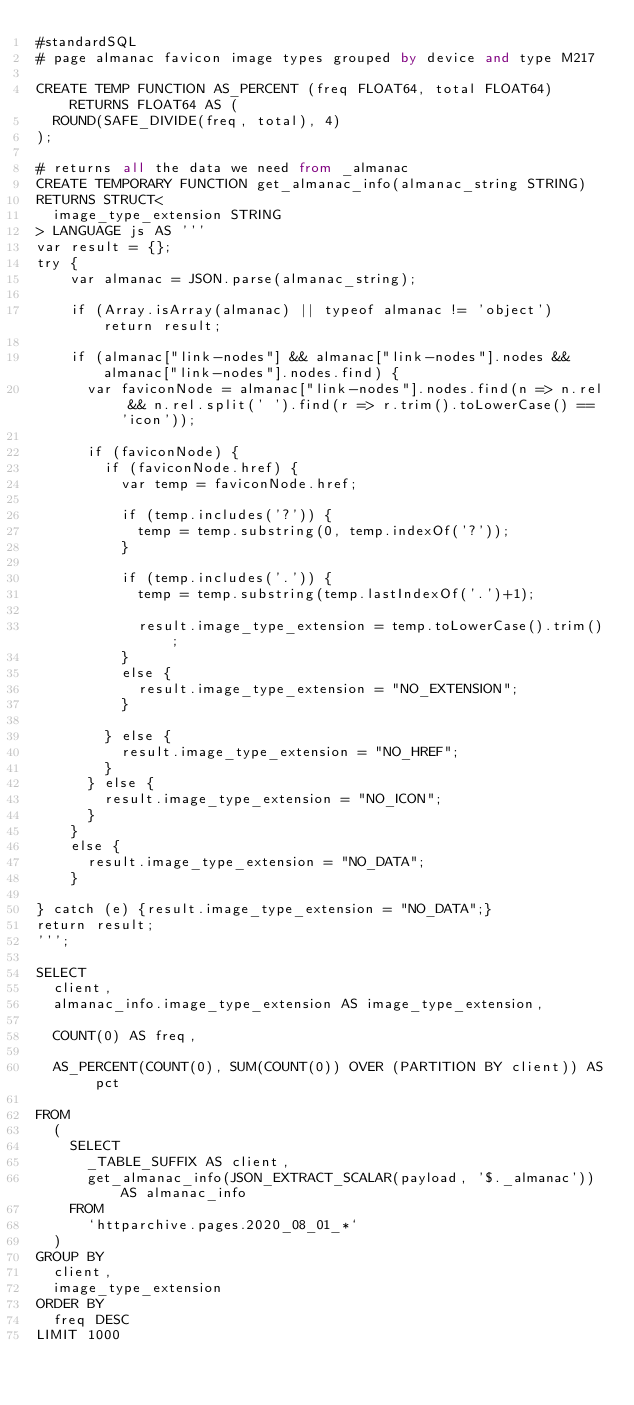<code> <loc_0><loc_0><loc_500><loc_500><_SQL_>#standardSQL
# page almanac favicon image types grouped by device and type M217

CREATE TEMP FUNCTION AS_PERCENT (freq FLOAT64, total FLOAT64) RETURNS FLOAT64 AS (
  ROUND(SAFE_DIVIDE(freq, total), 4)
);

# returns all the data we need from _almanac
CREATE TEMPORARY FUNCTION get_almanac_info(almanac_string STRING)
RETURNS STRUCT<
  image_type_extension STRING
> LANGUAGE js AS '''
var result = {};
try {
    var almanac = JSON.parse(almanac_string);

    if (Array.isArray(almanac) || typeof almanac != 'object') return result;

    if (almanac["link-nodes"] && almanac["link-nodes"].nodes && almanac["link-nodes"].nodes.find) {
      var faviconNode = almanac["link-nodes"].nodes.find(n => n.rel && n.rel.split(' ').find(r => r.trim().toLowerCase() == 'icon'));

      if (faviconNode) {
        if (faviconNode.href) {
          var temp = faviconNode.href;

          if (temp.includes('?')) {
            temp = temp.substring(0, temp.indexOf('?'));
          }

          if (temp.includes('.')) {
            temp = temp.substring(temp.lastIndexOf('.')+1);

            result.image_type_extension = temp.toLowerCase().trim();
          }
          else {
            result.image_type_extension = "NO_EXTENSION";
          }

        } else {
          result.image_type_extension = "NO_HREF";
        }
      } else {
        result.image_type_extension = "NO_ICON";
      }
    }
    else {
      result.image_type_extension = "NO_DATA";
    }

} catch (e) {result.image_type_extension = "NO_DATA";}
return result;
''';

SELECT
  client,
  almanac_info.image_type_extension AS image_type_extension,

  COUNT(0) AS freq,

  AS_PERCENT(COUNT(0), SUM(COUNT(0)) OVER (PARTITION BY client)) AS pct

FROM
  (
    SELECT
      _TABLE_SUFFIX AS client,
      get_almanac_info(JSON_EXTRACT_SCALAR(payload, '$._almanac')) AS almanac_info
    FROM
      `httparchive.pages.2020_08_01_*`
  )
GROUP BY
  client,
  image_type_extension
ORDER BY
  freq DESC
LIMIT 1000
</code> 